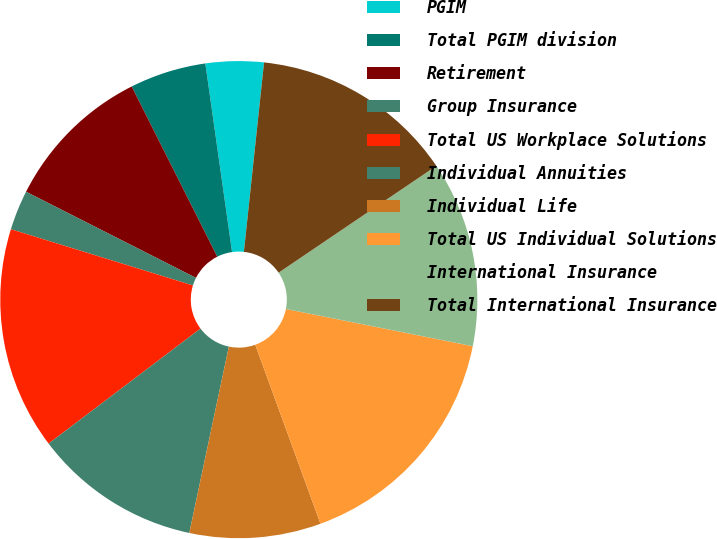<chart> <loc_0><loc_0><loc_500><loc_500><pie_chart><fcel>PGIM<fcel>Total PGIM division<fcel>Retirement<fcel>Group Insurance<fcel>Total US Workplace Solutions<fcel>Individual Annuities<fcel>Individual Life<fcel>Total US Individual Solutions<fcel>International Insurance<fcel>Total International Insurance<nl><fcel>3.93%<fcel>5.17%<fcel>10.12%<fcel>2.7%<fcel>15.08%<fcel>11.36%<fcel>8.89%<fcel>16.31%<fcel>12.6%<fcel>13.84%<nl></chart> 